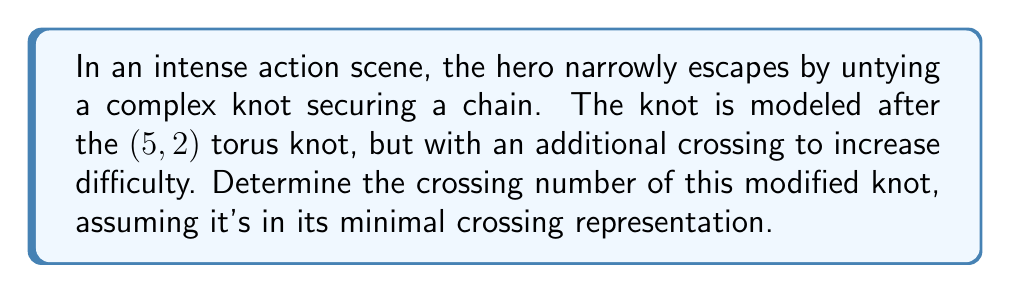Teach me how to tackle this problem. To solve this problem, we'll follow these steps:

1) First, recall that a $(p,q)$ torus knot has a crossing number of:

   $$c(T_{p,q}) = \min(p(q-1), q(p-1))$$

   where $p > q$.

2) For the $(5,2)$ torus knot:
   
   $$c(T_{5,2}) = \min(5(2-1), 2(5-1)) = \min(5, 8) = 5$$

3) The original $(5,2)$ torus knot has 5 crossings in its minimal representation.

4) The question states that an additional crossing was added to increase difficulty. This means we need to add 1 to our original crossing number.

5) Therefore, the crossing number of the modified knot is:

   $$5 + 1 = 6$$

This result aligns with the action-packed nature of the scene, as a knot with 6 crossings would indeed be complex and challenging to untie quickly, adding tension to the hero's escape.
Answer: 6 